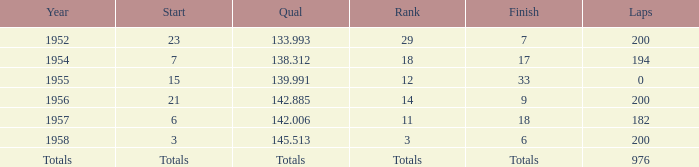What place did Jimmy Reece finish in 1957? 18.0. Help me parse the entirety of this table. {'header': ['Year', 'Start', 'Qual', 'Rank', 'Finish', 'Laps'], 'rows': [['1952', '23', '133.993', '29', '7', '200'], ['1954', '7', '138.312', '18', '17', '194'], ['1955', '15', '139.991', '12', '33', '0'], ['1956', '21', '142.885', '14', '9', '200'], ['1957', '6', '142.006', '11', '18', '182'], ['1958', '3', '145.513', '3', '6', '200'], ['Totals', 'Totals', 'Totals', 'Totals', 'Totals', '976']]} 